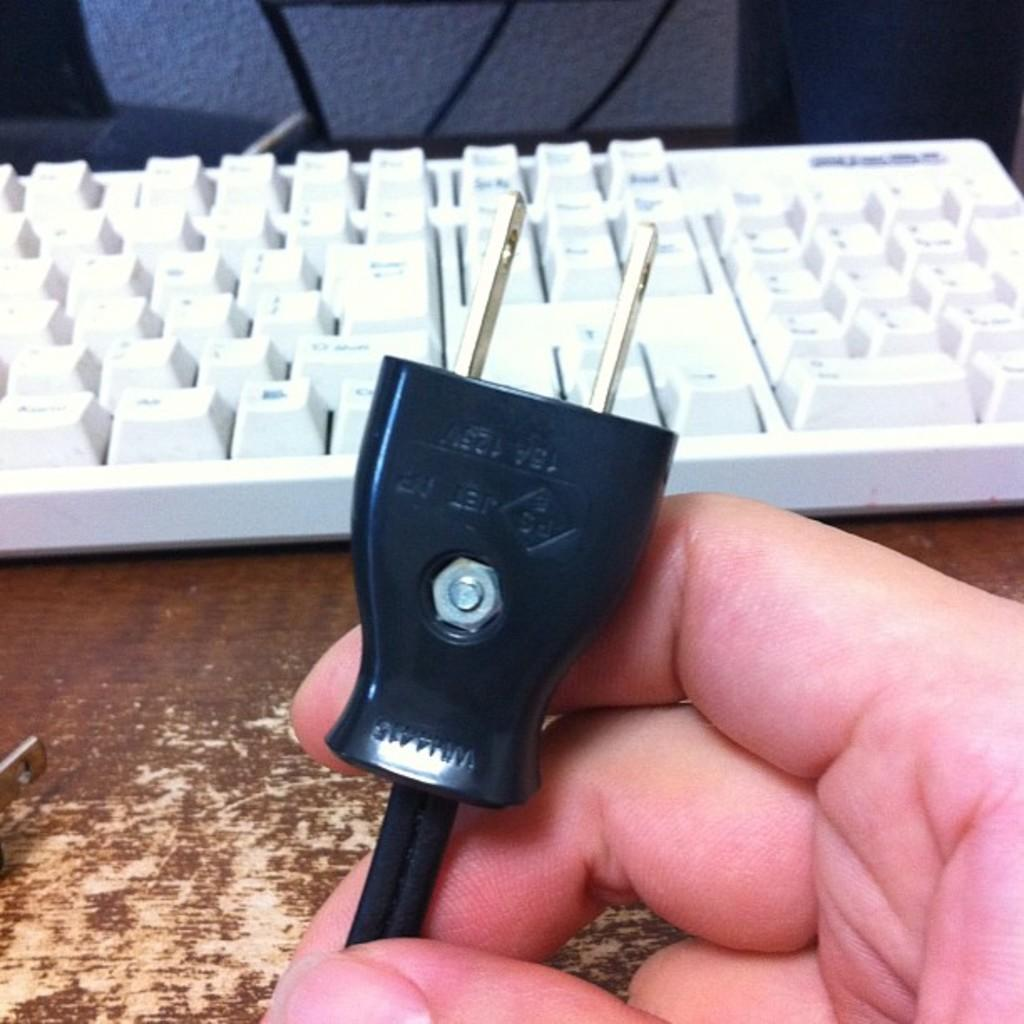What is the human hand holding in the image? The human hand is holding a black color pluck. What can be seen on the wooden surface in the image? There is a white color keyboard on a wooden surface. Can you describe the object at the top of the image? Unfortunately, there is no information provided about the object at the top of the image. What type of bread is being used to copy the keyboard in the image? There is no bread present in the image, nor is there any indication of copying. 